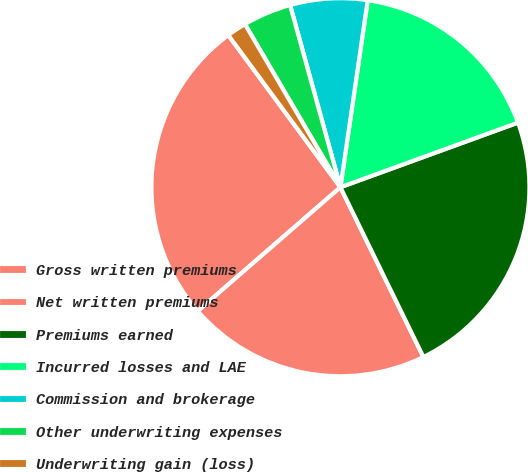Convert chart to OTSL. <chart><loc_0><loc_0><loc_500><loc_500><pie_chart><fcel>Gross written premiums<fcel>Net written premiums<fcel>Premiums earned<fcel>Incurred losses and LAE<fcel>Commission and brokerage<fcel>Other underwriting expenses<fcel>Underwriting gain (loss)<nl><fcel>26.27%<fcel>20.86%<fcel>23.32%<fcel>17.14%<fcel>6.6%<fcel>4.14%<fcel>1.68%<nl></chart> 